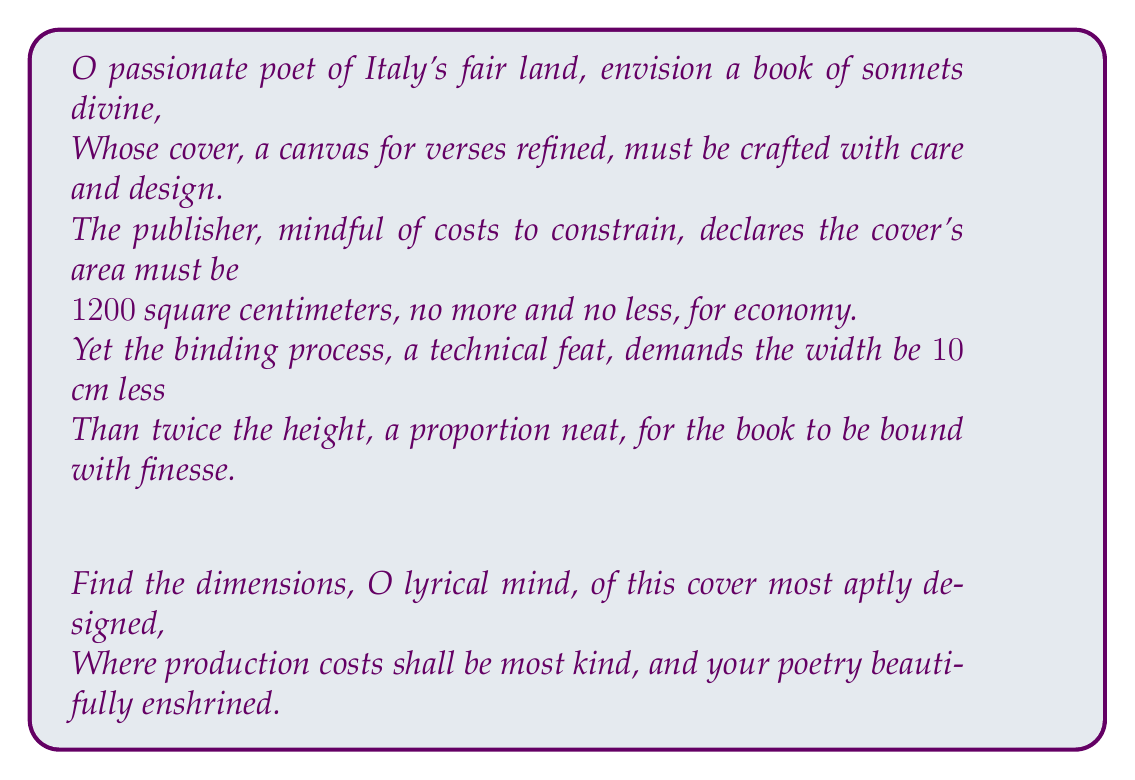Provide a solution to this math problem. Let us approach this poetic problem with mathematical precision:

1) Let $h$ represent the height of the book cover in centimeters.
2) Let $w$ represent the width of the book cover in centimeters.

Given:
- The area of the cover is 1200 cm²: $A = h \times w = 1200$
- The width is 10 cm less than twice the height: $w = 2h - 10$

Step 1: Substitute the width equation into the area equation:
$$h \times (2h - 10) = 1200$$

Step 2: Expand the equation:
$$2h^2 - 10h = 1200$$

Step 3: Rearrange to standard quadratic form:
$$2h^2 - 10h - 1200 = 0$$

Step 4: Solve using the quadratic formula: $h = \frac{-b \pm \sqrt{b^2 - 4ac}}{2a}$
Where $a=2$, $b=-10$, and $c=-1200$

$$h = \frac{10 \pm \sqrt{(-10)^2 - 4(2)(-1200)}}{2(2)}$$
$$h = \frac{10 \pm \sqrt{100 + 9600}}{4}$$
$$h = \frac{10 \pm \sqrt{9700}}{4}$$
$$h = \frac{10 \pm 98.49}{4}$$

Step 5: This gives us two solutions:
$$h_1 = \frac{10 + 98.49}{4} = 27.12 \text{ cm}$$
$$h_2 = \frac{10 - 98.49}{4} = -22.12 \text{ cm}$$

We discard the negative solution as dimensions cannot be negative.

Step 6: Calculate the width using $w = 2h - 10$:
$$w = 2(27.12) - 10 = 44.24 \text{ cm}$$

Step 7: Verify the area:
$$A = 27.12 \times 44.24 = 1200 \text{ cm}^2$$

Thus, we have found the optimal dimensions that satisfy all conditions.
Answer: The optimal dimensions for the book cover are:
Height: $27.12$ cm
Width: $44.24$ cm 